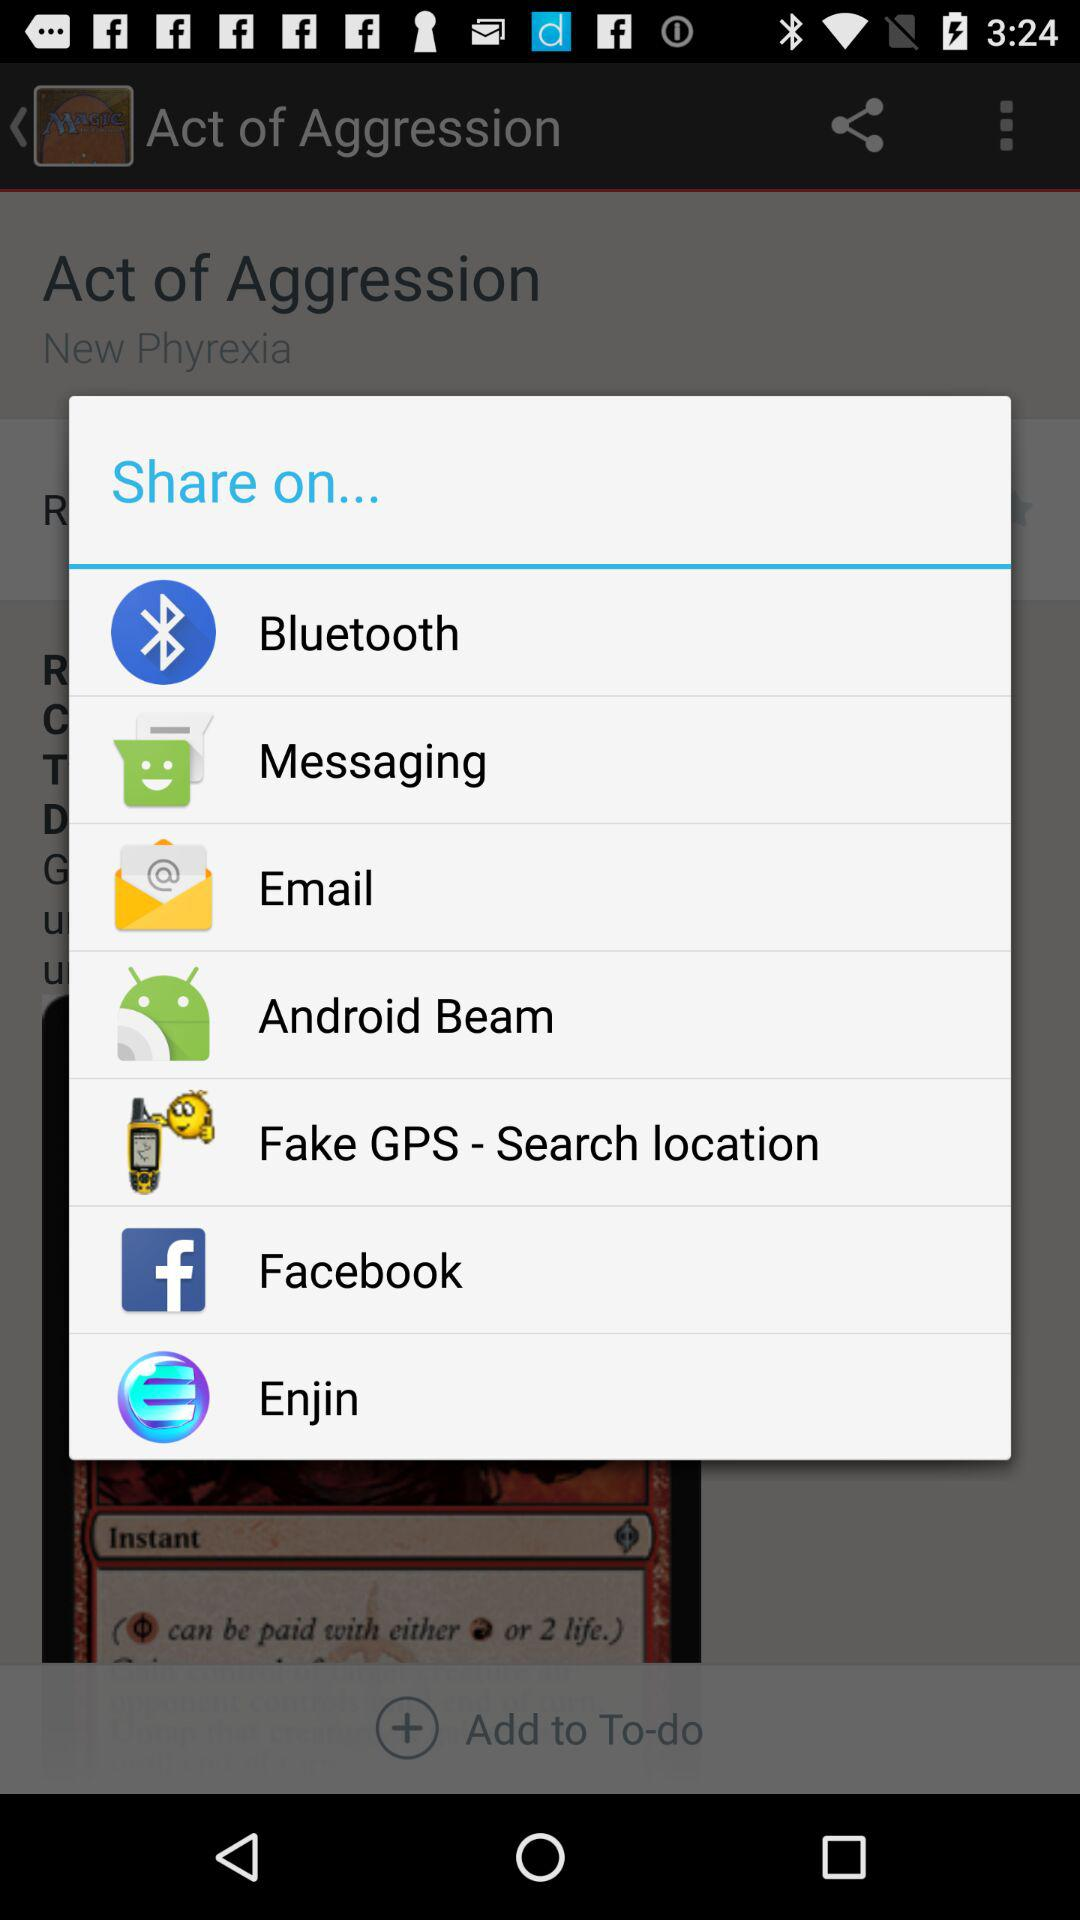Is there anything added to the to-do list?
When the provided information is insufficient, respond with <no answer>. <no answer> 